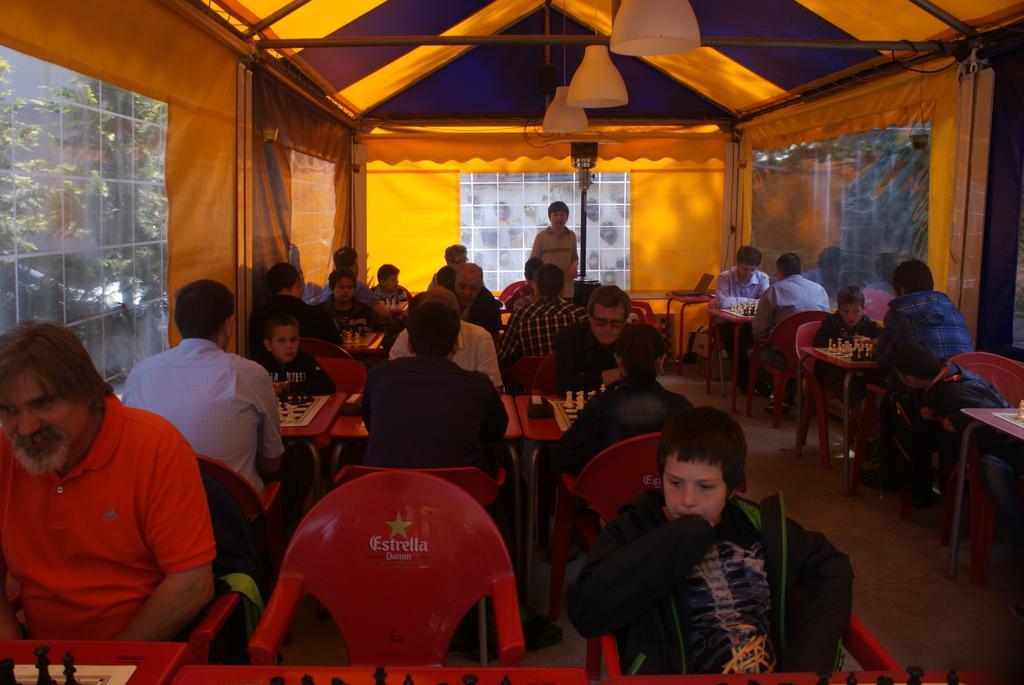What type of establishment are the people in the image located in? The people are sitting in a restaurant. How are the people arranged in the restaurant? Each person is seated at their own table. What type of furniture are the people using to sit? The people are sitting in chairs. What can be seen near the guy in the image? There is a tent near the guy. What type of lighting is present in the restaurant? There are lights hanging from the ceiling. What channel is the dinner being served on in the image? There is no dinner being served on a channel in the image; it is a physical meal being eaten in the restaurant. 